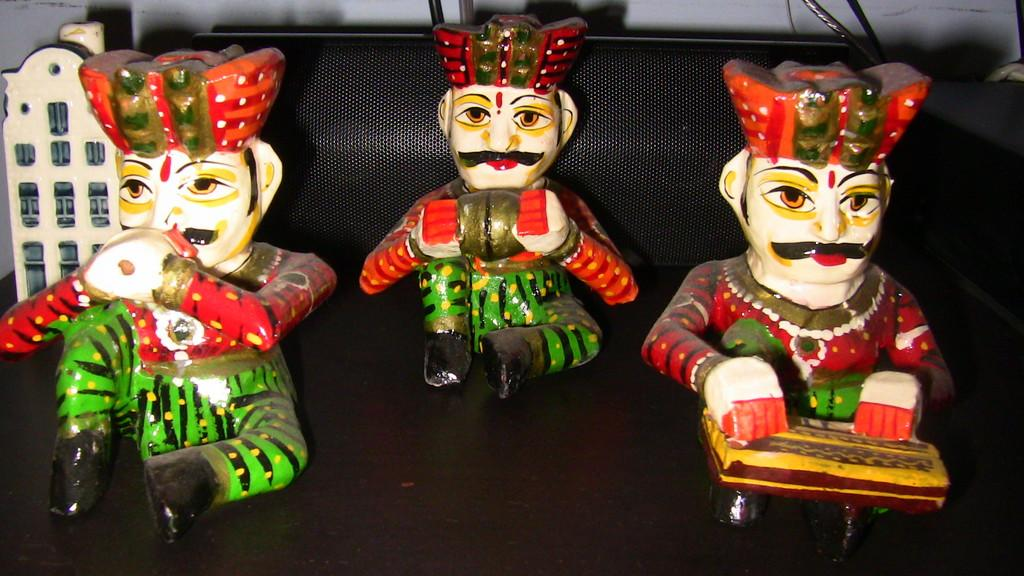What type of objects are present on the table in the image? There are dolls present in the image. Where are the dolls located? The dolls are on a table. What type of body is visible in the image? There is no body present in the image; it features dolls on a table. What is the mass of the bun in the image? There is no bun present in the image, so its mass cannot be determined. 